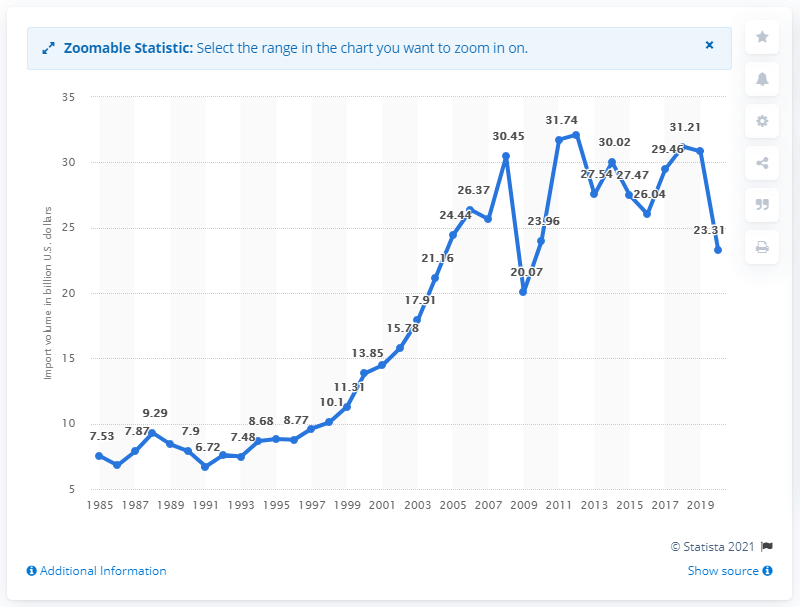What additional information would be helpful to better understand the context of U.S. imports from Brazil in 2020? Additional context to better understand U.S. imports from Brazil in 2020 could include factors such as the economic policies in place, the impact of global events like the COVID-19 pandemic on trade, the main commodities involved in the trade, and the comparative data on exports from the U.S. to Brazil. 